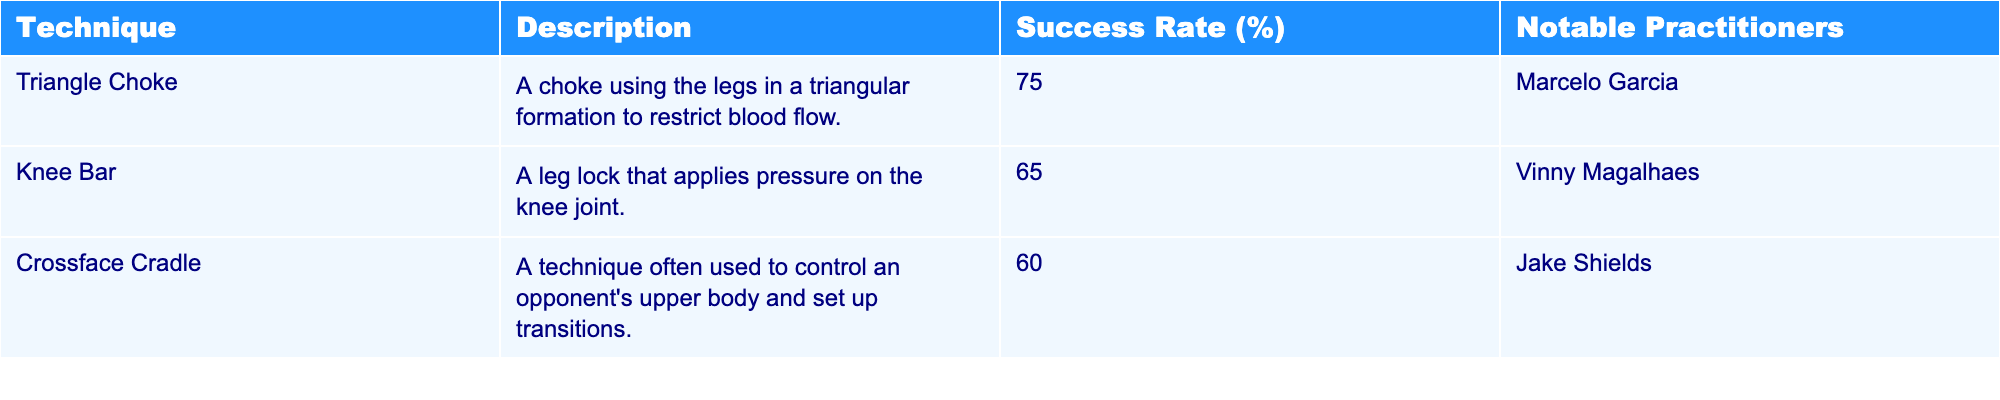What is the success rate of the Triangle Choke? The table clearly states that the success rate for the Triangle Choke technique is indicated in the "Success Rate (%)" column next to it, which is 75%.
Answer: 75% Who is a notable practitioner of the Knee Bar technique? In the table, the "Notable Practitioners" column lists Vinny Magalhaes as the practitioner associated with the Knee Bar technique.
Answer: Vinny Magalhaes What technique has a success rate of 60%? By examining the table, I can see that the Crossface Cradle technique is listed with a corresponding success rate of 60%.
Answer: Crossface Cradle What is the average success rate of the techniques listed? To calculate the average, I sum the success rates: 75 + 65 + 60 = 200. There are 3 techniques, so the average is 200 / 3 = 66.67.
Answer: 66.67 Is the success rate of the Triangle Choke greater than that of the Knee Bar? The Triangle Choke has a success rate of 75%, and the Knee Bar has a success rate of 65%. Since 75 is greater than 65, this statement is true.
Answer: Yes If we consider only the top two techniques by success rate, what is their average success rate? The top two techniques are the Triangle Choke (75%) and Knee Bar (65%). Adding these gives 75 + 65 = 140. Dividing by 2 (the count of these techniques) gives 140 / 2 = 70.
Answer: 70 Which technique has the lowest success rate? In the "Success Rate (%)" column, I observe that the Crossface Cradle has the lowest listing at 60%.
Answer: Crossface Cradle Would it be correct to say that all techniques have a success rate of at least 60%? Upon reviewing the success rates: Triangle Choke (75%), Knee Bar (65%), and Crossface Cradle (60%), I see that all are above 60%. Therefore, the statement is true.
Answer: Yes What is the difference in success rates between the Triangle Choke and the Crossface Cradle? The Triangle Choke has a success rate of 75%, and the Crossface Cradle has 60%. The difference is calculated as 75 - 60, which equals 15.
Answer: 15 